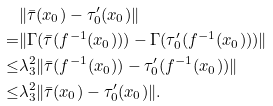<formula> <loc_0><loc_0><loc_500><loc_500>& \| \bar { \tau } ( x _ { 0 } ) - \tau _ { 0 } ^ { \prime } ( x _ { 0 } ) \| \\ = & \| \Gamma ( \bar { \tau } ( f ^ { - 1 } ( x _ { 0 } ) ) ) - \Gamma ( \tau _ { 0 } ^ { \prime } ( f ^ { - 1 } ( x _ { 0 } ) ) ) \| \\ \leq & \lambda _ { 3 } ^ { 2 } \| \bar { \tau } ( f ^ { - 1 } ( x _ { 0 } ) ) - \tau _ { 0 } ^ { \prime } ( f ^ { - 1 } ( x _ { 0 } ) ) \| \\ \leq & \lambda _ { 3 } ^ { 2 } \| \bar { \tau } ( x _ { 0 } ) - \tau _ { 0 } ^ { \prime } ( x _ { 0 } ) \| .</formula> 